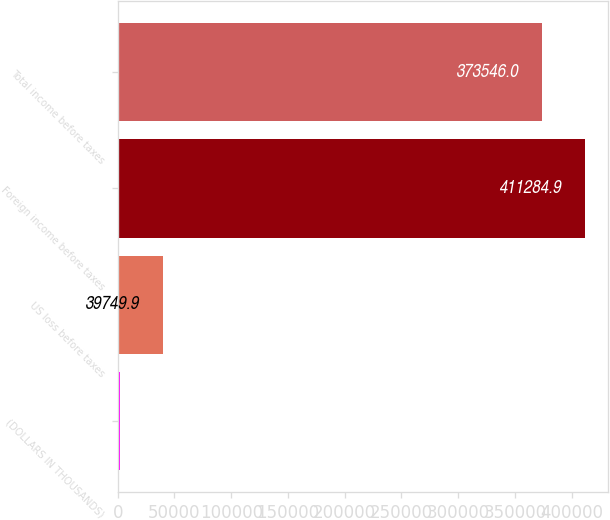Convert chart to OTSL. <chart><loc_0><loc_0><loc_500><loc_500><bar_chart><fcel>(DOLLARS IN THOUSANDS)<fcel>US loss before taxes<fcel>Foreign income before taxes<fcel>Total income before taxes<nl><fcel>2011<fcel>39749.9<fcel>411285<fcel>373546<nl></chart> 